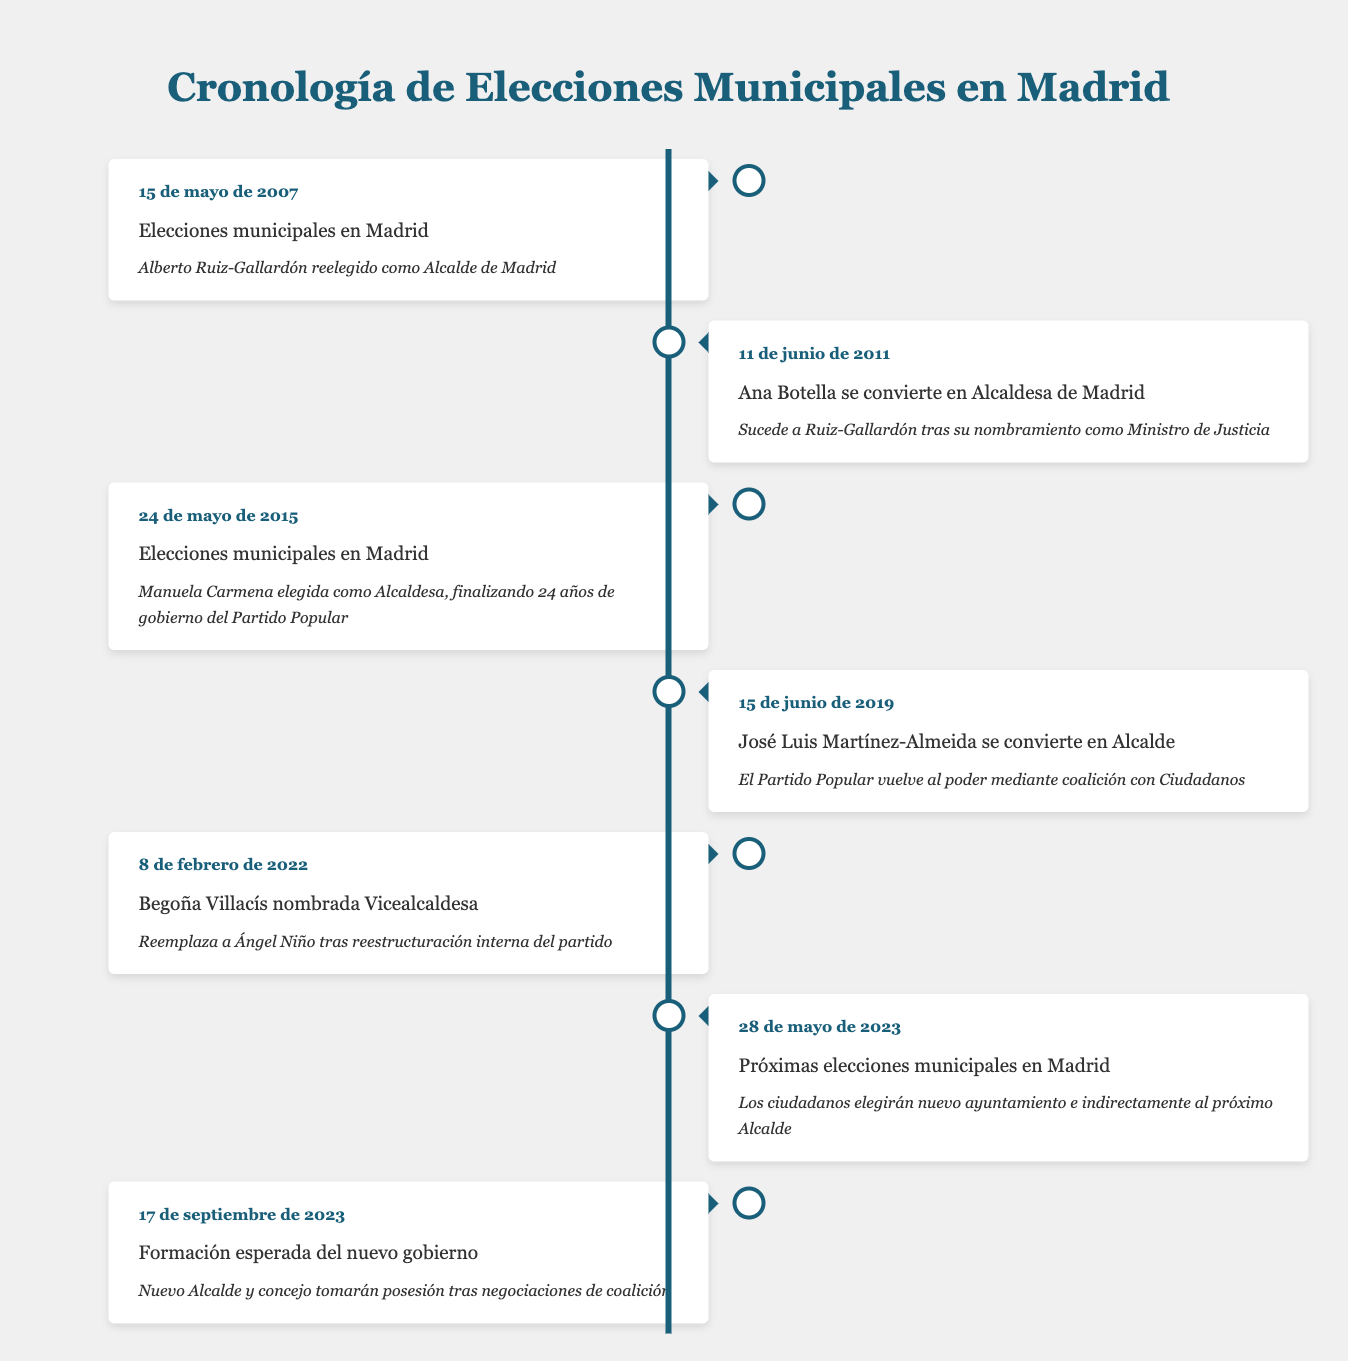What date were the municipal elections held in 2007? The table shows the event on May 15, 2007, indicating that municipal elections were held in Madrid on that date.
Answer: May 15, 2007 Who succeeded Alberto Ruiz-Gallardón as Mayor of Madrid? According to the entry on June 11, 2011, Ana Botella became Mayor of Madrid after succeeding Ruiz-Gallardón.
Answer: Ana Botella How many years did the People's Party govern before the 2015 municipal elections? The People's Party was in power from the entry in 2007 until the 2015 elections, which is an 8-year span.
Answer: 8 years Did José Luis Martínez-Almeida become Mayor of Madrid before or after 2019? The information states that José Luis Martínez-Almeida became Mayor on June 15, 2019, confirming that he took office in 2019.
Answer: After What significant event occurred on May 24, 2015? The table indicates that on this date, Manuela Carmena was elected as Mayor, marking the end of 24 years of People's Party rule.
Answer: Manuela Carmena was elected Mayor What was the position of Begoña Villacís after February 8, 2022? The entry shows that Begoña Villacís was appointed as Deputy Mayor, confirming her position following internal restructuring.
Answer: Deputy Mayor How long is it expected to take for the new government to be formed after the municipal elections in 2023? The municipal elections were scheduled for May 28, 2023, and the new government's formation is expected on September 17, 2023. Therefore, it will take about 3.5 months to form the new government.
Answer: About 3.5 months Was there a coalition involved in the transition of mayorship in 2019? The description states that the People's Party returned to power through a coalition with Ciudadanos, confirming the coalition's involvement.
Answer: Yes Who served as Mayor after Manuela Carmena? The timeline shows that José Luis Martínez-Almeida took over as Mayor on June 15, 2019, after Manuela Carmena.
Answer: José Luis Martínez-Almeida 